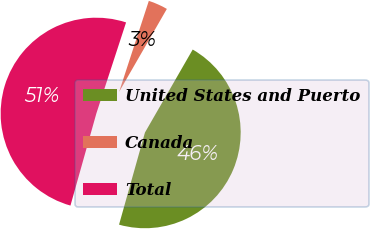Convert chart to OTSL. <chart><loc_0><loc_0><loc_500><loc_500><pie_chart><fcel>United States and Puerto<fcel>Canada<fcel>Total<nl><fcel>46.05%<fcel>3.29%<fcel>50.66%<nl></chart> 